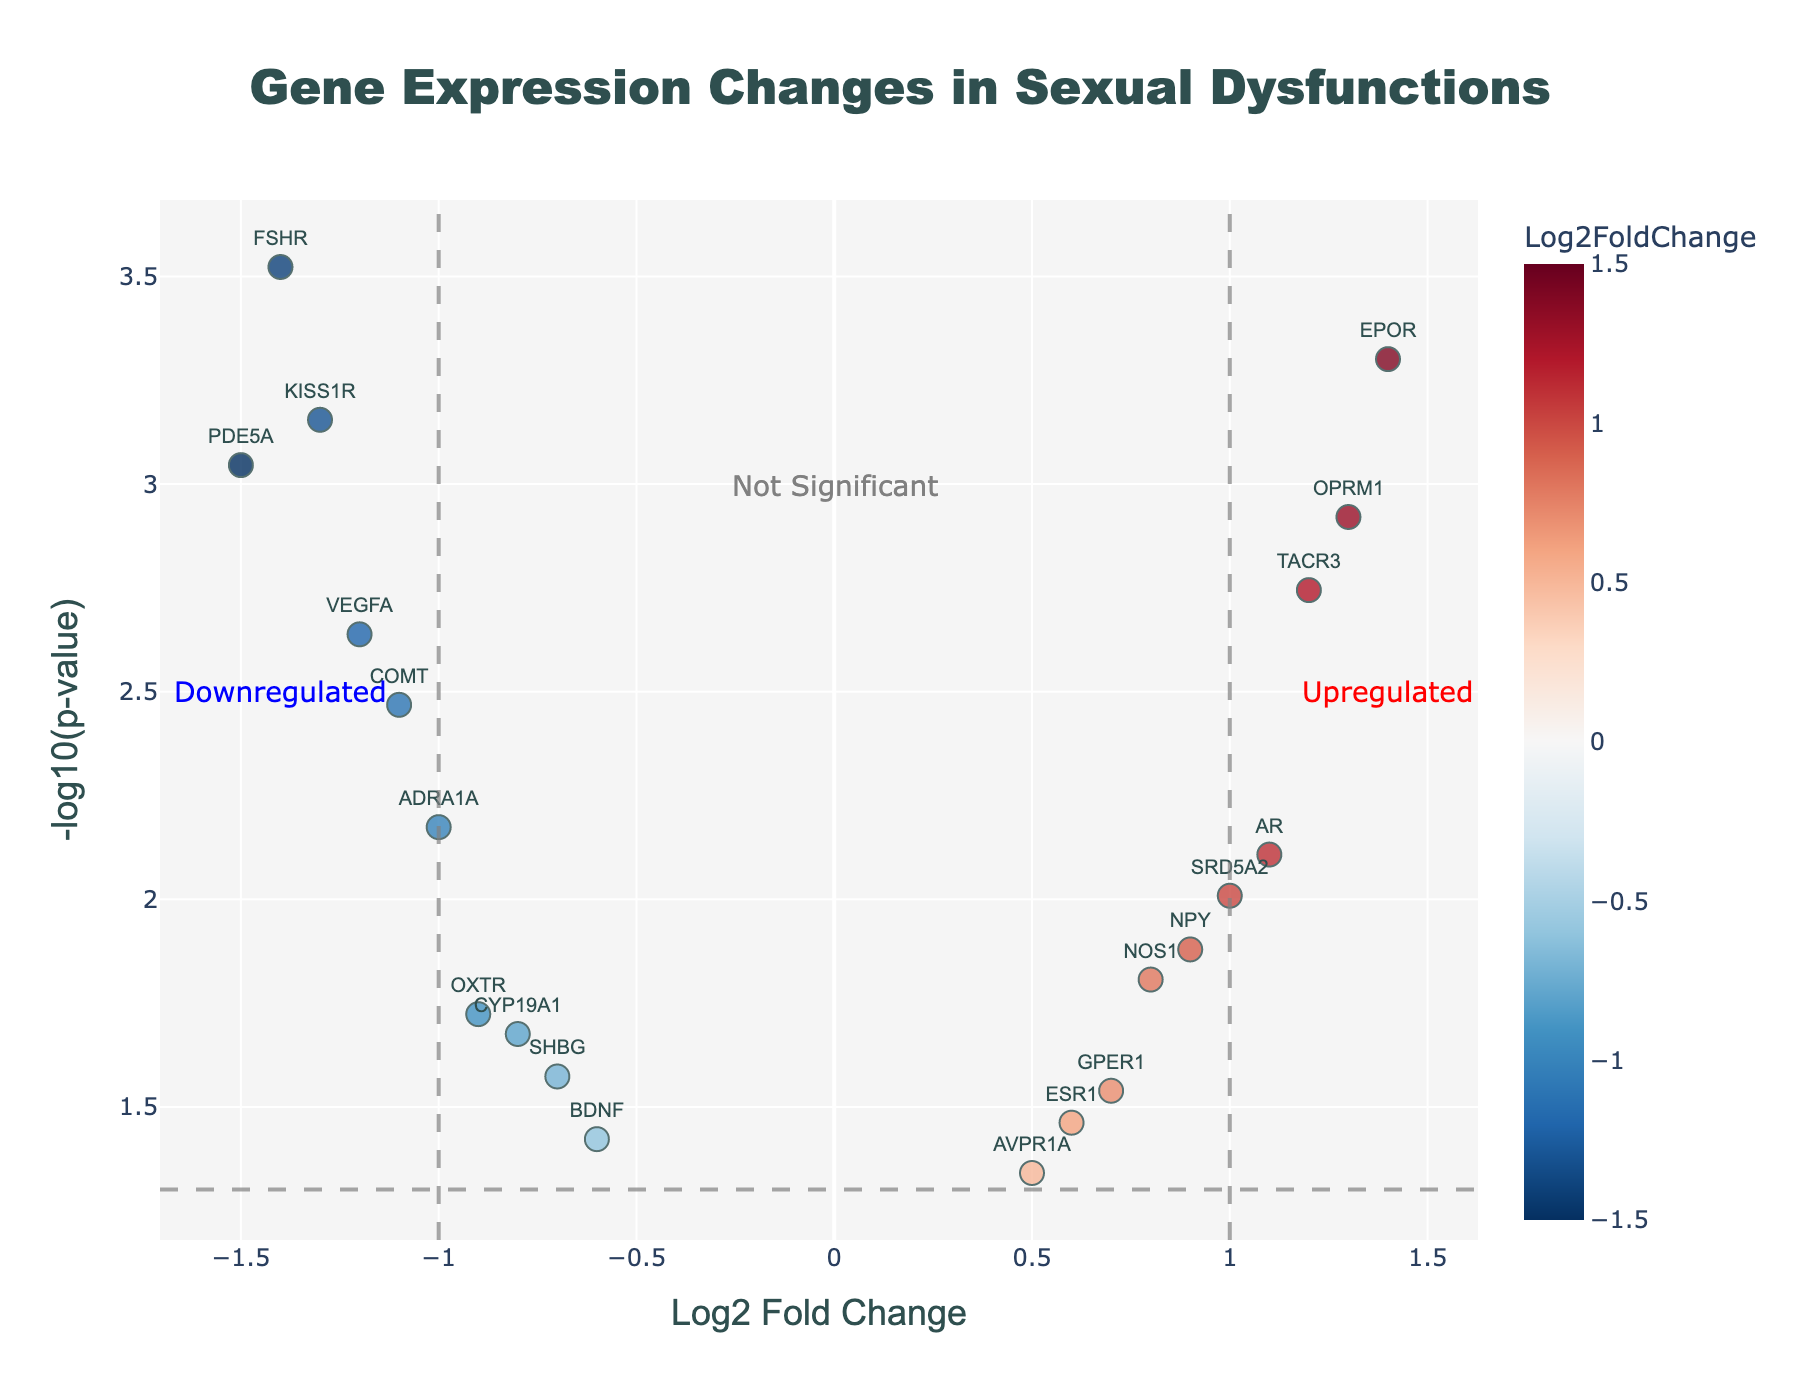what is the title of the plot? The title of the plot is displayed at the top center of the figure. The title text is "Gene Expression Changes in Sexual Dysfunctions".
Answer: Gene Expression Changes in Sexual Dysfunctions How many genes are considered significantly upregulated? To determine the significantly upregulated genes, look at genes with a Log2 Fold Change greater than 1 and -log10(p-value) greater than 1.301 (which corresponds to a p-value less than 0.05). The genes AR, OPRM1, TACR3, SRD5A2, and EPOR all meet these criteria.
Answer: 5 Which gene has the highest -log10(p-value) indicating the most significant change? To find the highest -log10(p-value), locate the point that reaches the highest on the y-axis. The gene EPOR has the highest -log10(p-value) with a value higher than 3.
Answer: EPOR What is the -log10(p-value) threshold line drawn at? The -log10(p-value) threshold line is the horizontal dashed line, which is drawn at -log10(0.05). Calculating that value gives approximately 1.3010.
Answer: 1.3010 Which gene is the most downregulated according to the plot? The most downregulated gene is the one with the lowest Log2 Fold Change (most negative value) and significantly different (-log10(p-value) > 1.301). The gene PDE5A fits this criterion with a Log2 Fold Change around -1.5.
Answer: PDE5A How many genes have p-values greater than 0.05, making them not significant? To count the genes with p-values greater than 0.05, we look for points with -log10(p-value) below 1.301. These genes are ESR1, AVPR1A, BDNF, and GPER1.
Answer: 4 Out of the significantly downregulated genes, which one has the least negative Log2 Fold Change? Narrow down to downregulated genes with a Log2 Fold Change less than -1 and a -log10(p-value) greater than 1.301. Among these, ADRA1A has the least negative value at -1.0.
Answer: ADRA1A 